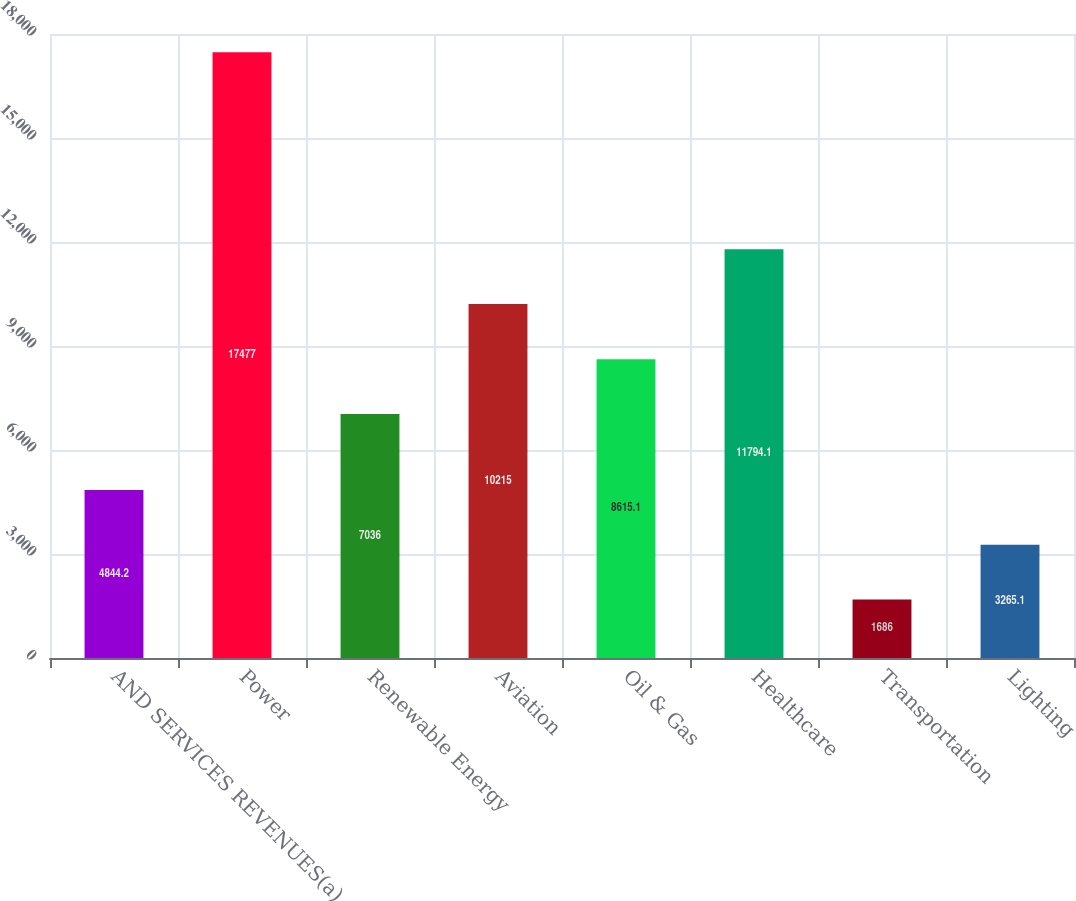Convert chart. <chart><loc_0><loc_0><loc_500><loc_500><bar_chart><fcel>AND SERVICES REVENUES(a)<fcel>Power<fcel>Renewable Energy<fcel>Aviation<fcel>Oil & Gas<fcel>Healthcare<fcel>Transportation<fcel>Lighting<nl><fcel>4844.2<fcel>17477<fcel>7036<fcel>10215<fcel>8615.1<fcel>11794.1<fcel>1686<fcel>3265.1<nl></chart> 